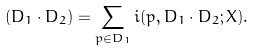<formula> <loc_0><loc_0><loc_500><loc_500>( D _ { 1 } \cdot D _ { 2 } ) = \sum _ { p \in D _ { 1 } } i ( p , D _ { 1 } \cdot D _ { 2 } ; X ) .</formula> 